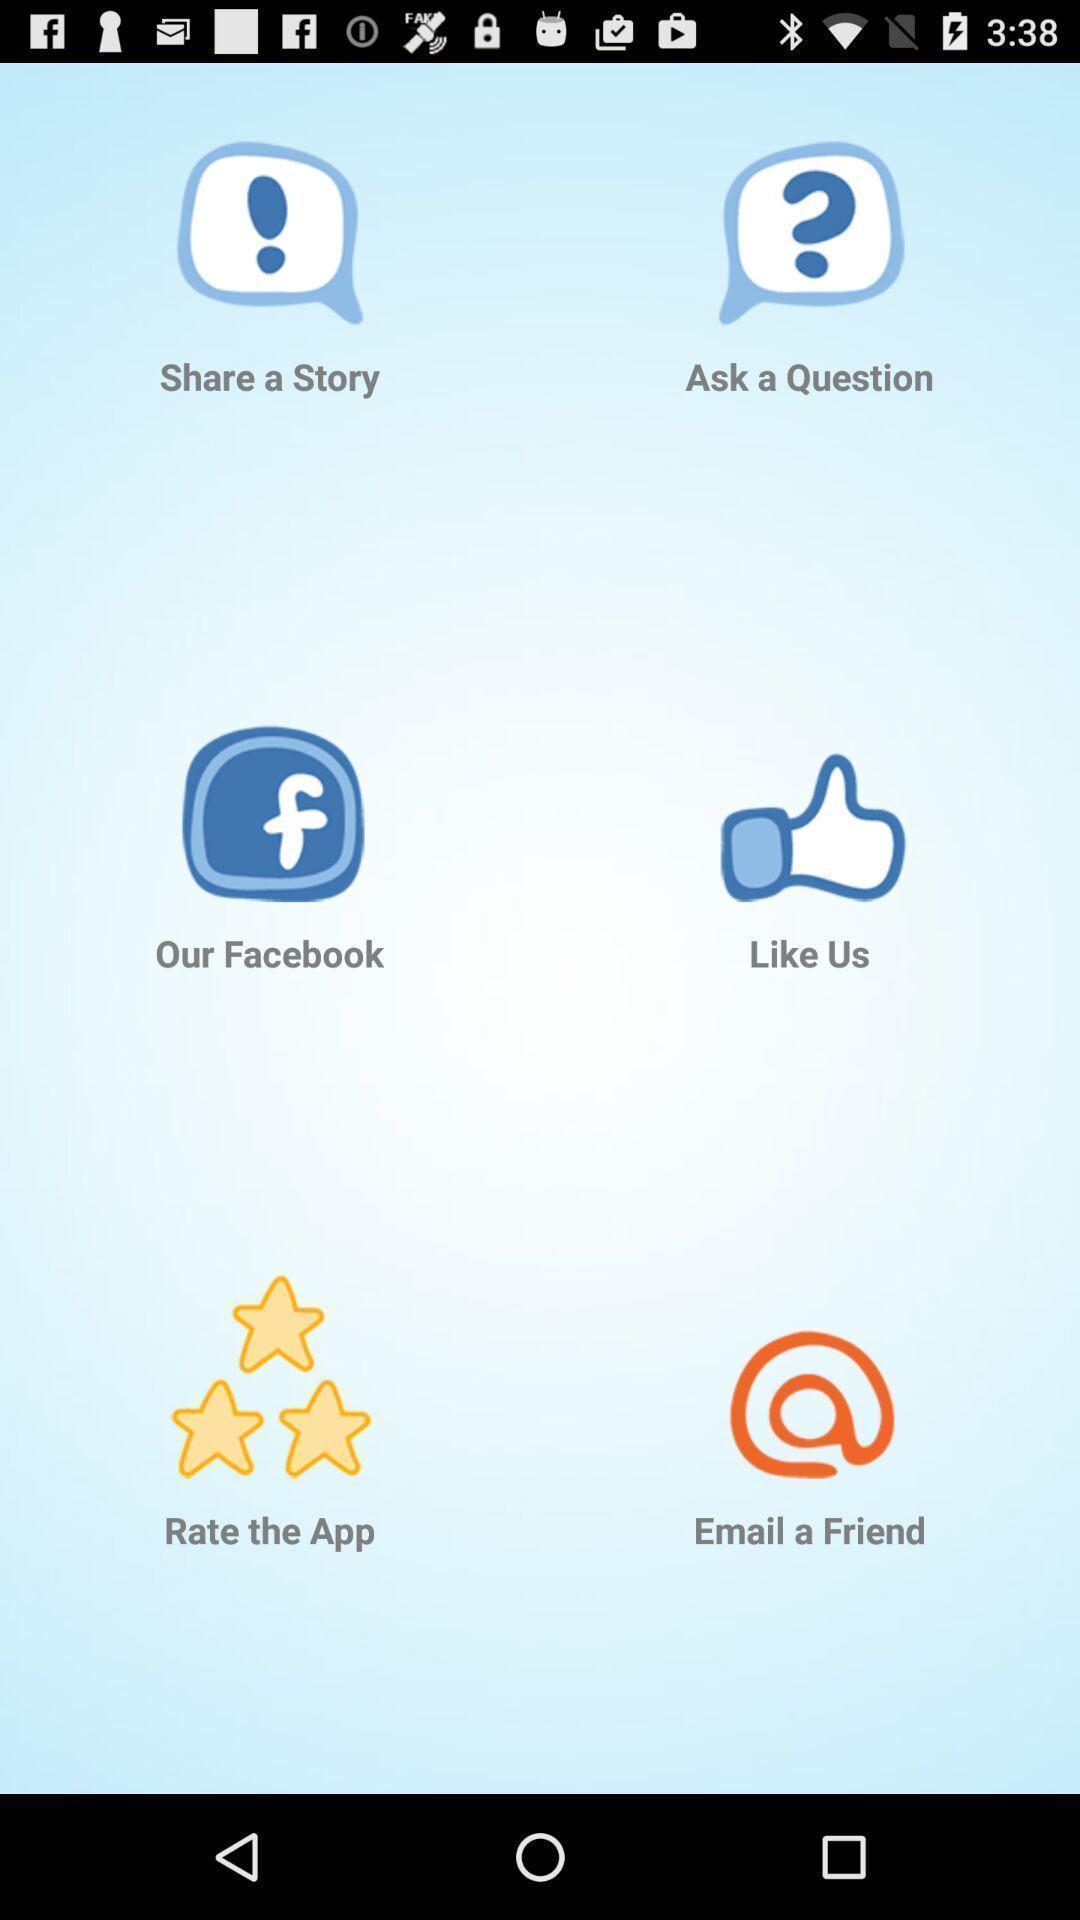What can you discern from this picture? Window displaying different apps with icons. 